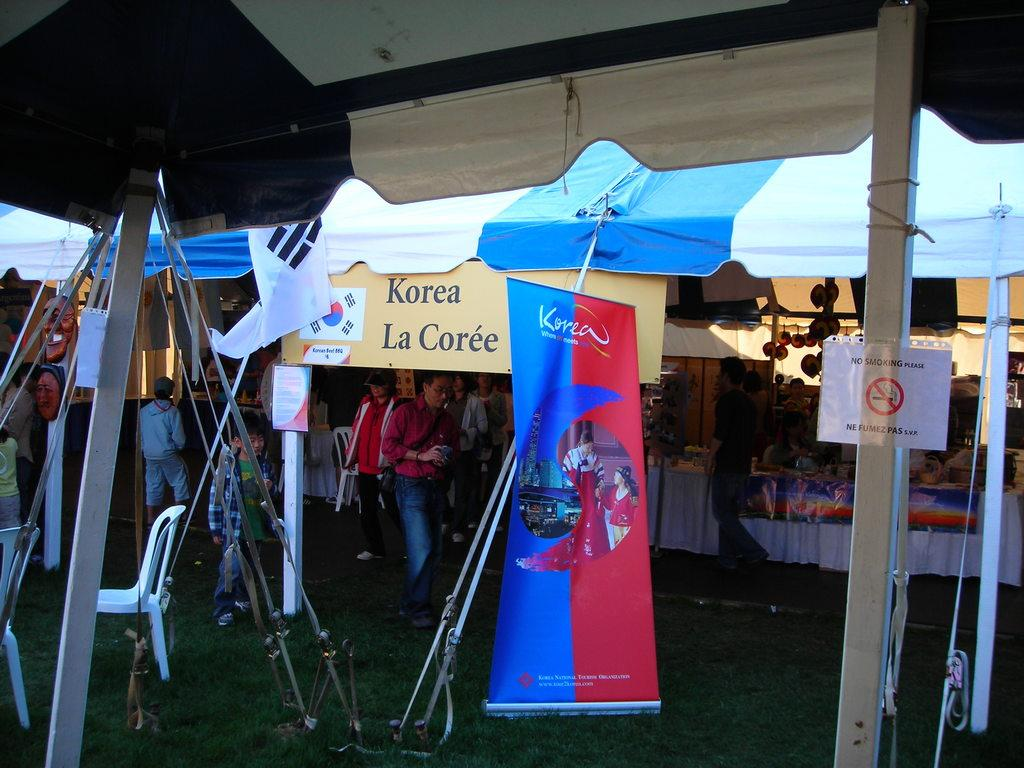How many people are in the image? There is a group of people in the image, but the exact number cannot be determined from the provided facts. What is on the ground in the image? Chairs, tents, and grass are visible on the ground in the image. What is the purpose of the board in the image? The purpose of the board in the image cannot be determined from the provided facts. What do the banners with text in the image say? The text on the banners in the image cannot be determined from the provided facts. What are the poles used for in the image? The purpose of the poles in the image cannot be determined from the provided facts. What type of vegetation is visible in the image? Grass is visible in the image. What is the flag attached to in the image? The flag is attached to a pole in the image. What type of mint is growing in the image? There is no mint present in the image. What color is the shirt worn by the person in the image? There is no person or shirt visible in the image. 